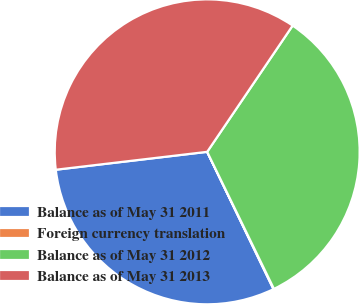<chart> <loc_0><loc_0><loc_500><loc_500><pie_chart><fcel>Balance as of May 31 2011<fcel>Foreign currency translation<fcel>Balance as of May 31 2012<fcel>Balance as of May 31 2013<nl><fcel>30.28%<fcel>0.06%<fcel>33.31%<fcel>36.34%<nl></chart> 